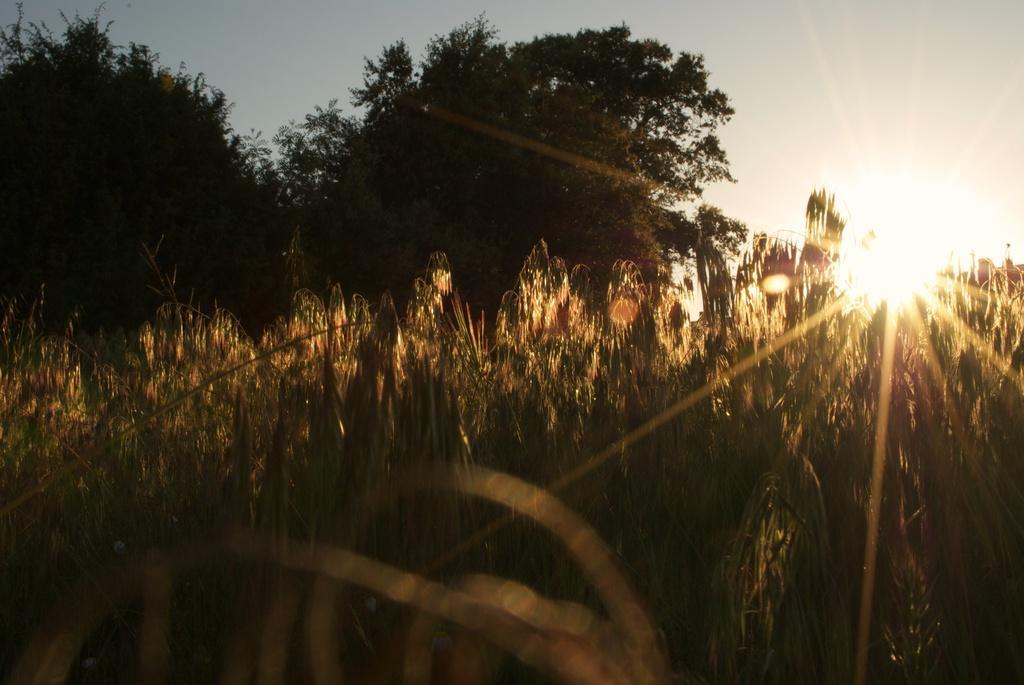Please provide a concise description of this image. There are plants and trees on ground. In the background, there is sun in the sky. 